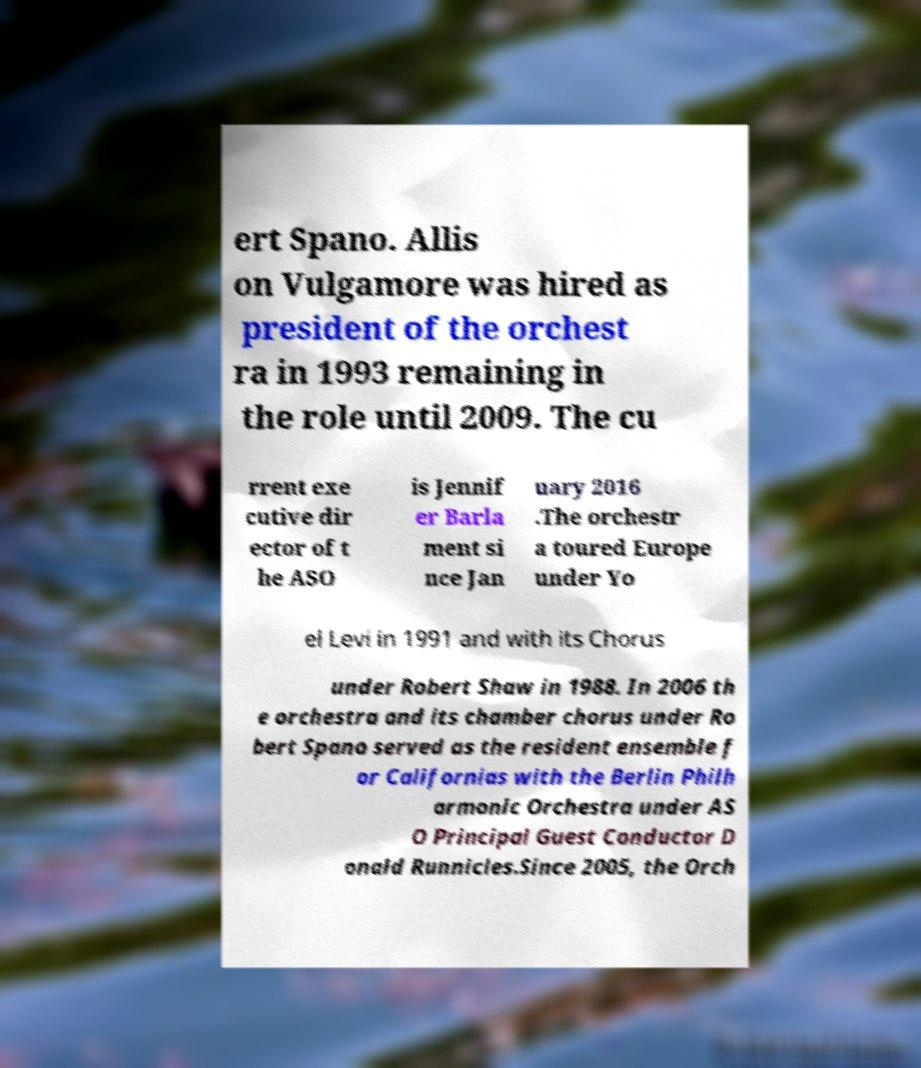There's text embedded in this image that I need extracted. Can you transcribe it verbatim? ert Spano. Allis on Vulgamore was hired as president of the orchest ra in 1993 remaining in the role until 2009. The cu rrent exe cutive dir ector of t he ASO is Jennif er Barla ment si nce Jan uary 2016 .The orchestr a toured Europe under Yo el Levi in 1991 and with its Chorus under Robert Shaw in 1988. In 2006 th e orchestra and its chamber chorus under Ro bert Spano served as the resident ensemble f or Californias with the Berlin Philh armonic Orchestra under AS O Principal Guest Conductor D onald Runnicles.Since 2005, the Orch 